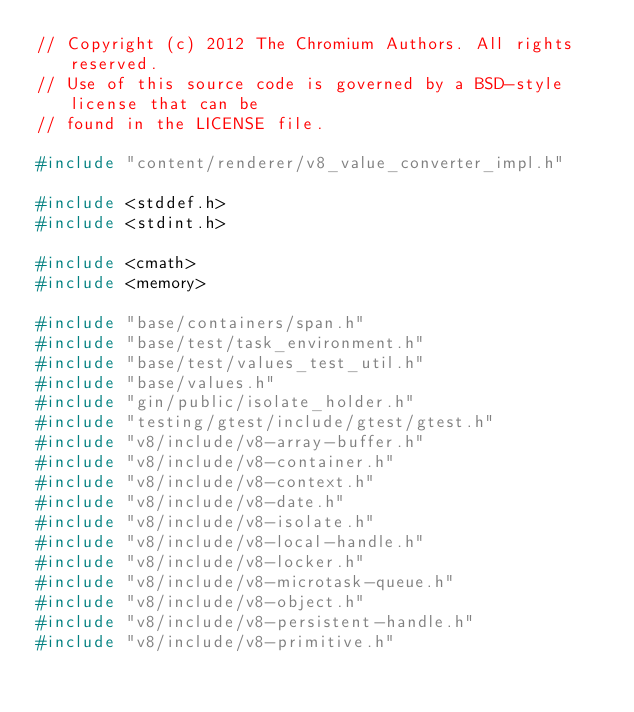Convert code to text. <code><loc_0><loc_0><loc_500><loc_500><_C++_>// Copyright (c) 2012 The Chromium Authors. All rights reserved.
// Use of this source code is governed by a BSD-style license that can be
// found in the LICENSE file.

#include "content/renderer/v8_value_converter_impl.h"

#include <stddef.h>
#include <stdint.h>

#include <cmath>
#include <memory>

#include "base/containers/span.h"
#include "base/test/task_environment.h"
#include "base/test/values_test_util.h"
#include "base/values.h"
#include "gin/public/isolate_holder.h"
#include "testing/gtest/include/gtest/gtest.h"
#include "v8/include/v8-array-buffer.h"
#include "v8/include/v8-container.h"
#include "v8/include/v8-context.h"
#include "v8/include/v8-date.h"
#include "v8/include/v8-isolate.h"
#include "v8/include/v8-local-handle.h"
#include "v8/include/v8-locker.h"
#include "v8/include/v8-microtask-queue.h"
#include "v8/include/v8-object.h"
#include "v8/include/v8-persistent-handle.h"
#include "v8/include/v8-primitive.h"</code> 